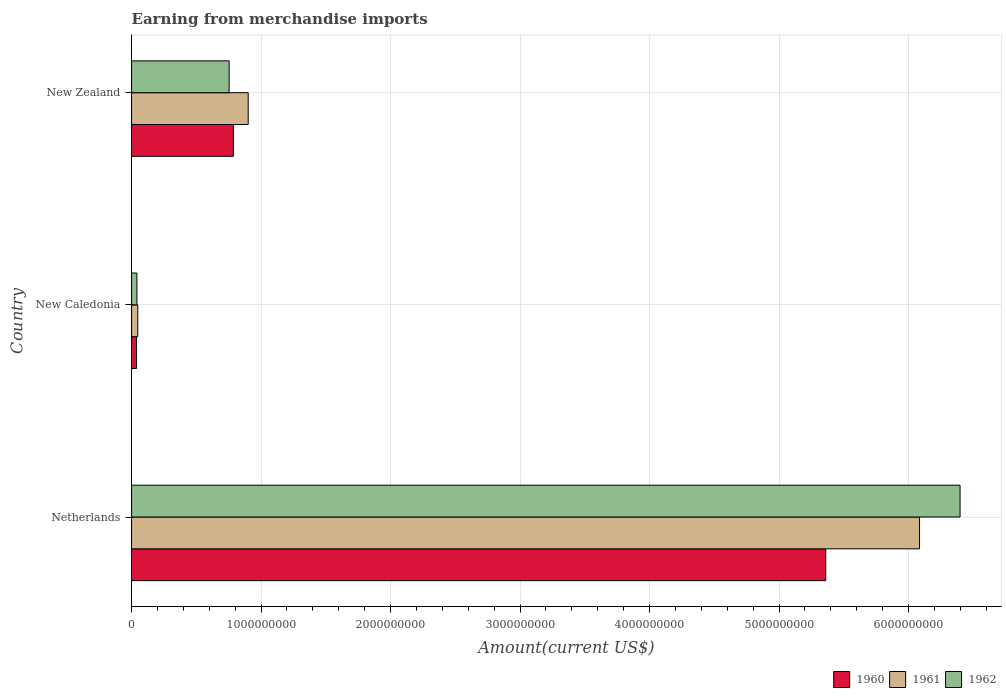How many different coloured bars are there?
Provide a short and direct response. 3. How many groups of bars are there?
Your answer should be compact. 3. Are the number of bars per tick equal to the number of legend labels?
Keep it short and to the point. Yes. Are the number of bars on each tick of the Y-axis equal?
Offer a terse response. Yes. How many bars are there on the 3rd tick from the bottom?
Make the answer very short. 3. What is the label of the 1st group of bars from the top?
Your response must be concise. New Zealand. What is the amount earned from merchandise imports in 1960 in Netherlands?
Make the answer very short. 5.36e+09. Across all countries, what is the maximum amount earned from merchandise imports in 1960?
Offer a very short reply. 5.36e+09. Across all countries, what is the minimum amount earned from merchandise imports in 1962?
Your response must be concise. 4.10e+07. In which country was the amount earned from merchandise imports in 1960 minimum?
Offer a very short reply. New Caledonia. What is the total amount earned from merchandise imports in 1961 in the graph?
Make the answer very short. 7.03e+09. What is the difference between the amount earned from merchandise imports in 1962 in New Caledonia and that in New Zealand?
Your answer should be very brief. -7.12e+08. What is the difference between the amount earned from merchandise imports in 1960 in New Zealand and the amount earned from merchandise imports in 1961 in Netherlands?
Keep it short and to the point. -5.30e+09. What is the average amount earned from merchandise imports in 1960 per country?
Provide a succinct answer. 2.06e+09. What is the difference between the amount earned from merchandise imports in 1960 and amount earned from merchandise imports in 1962 in New Zealand?
Keep it short and to the point. 3.28e+07. In how many countries, is the amount earned from merchandise imports in 1961 greater than 6000000000 US$?
Provide a short and direct response. 1. What is the ratio of the amount earned from merchandise imports in 1960 in Netherlands to that in New Caledonia?
Your answer should be compact. 141.08. What is the difference between the highest and the second highest amount earned from merchandise imports in 1960?
Provide a succinct answer. 4.57e+09. What is the difference between the highest and the lowest amount earned from merchandise imports in 1961?
Your answer should be compact. 6.04e+09. Is the sum of the amount earned from merchandise imports in 1961 in New Caledonia and New Zealand greater than the maximum amount earned from merchandise imports in 1962 across all countries?
Your answer should be compact. No. What does the 3rd bar from the top in Netherlands represents?
Your answer should be very brief. 1960. How many bars are there?
Provide a succinct answer. 9. What is the difference between two consecutive major ticks on the X-axis?
Give a very brief answer. 1.00e+09. Does the graph contain any zero values?
Offer a very short reply. No. Does the graph contain grids?
Your answer should be very brief. Yes. How are the legend labels stacked?
Give a very brief answer. Horizontal. What is the title of the graph?
Ensure brevity in your answer.  Earning from merchandise imports. Does "1963" appear as one of the legend labels in the graph?
Your answer should be compact. No. What is the label or title of the X-axis?
Offer a very short reply. Amount(current US$). What is the label or title of the Y-axis?
Keep it short and to the point. Country. What is the Amount(current US$) of 1960 in Netherlands?
Your answer should be very brief. 5.36e+09. What is the Amount(current US$) of 1961 in Netherlands?
Keep it short and to the point. 6.09e+09. What is the Amount(current US$) in 1962 in Netherlands?
Your response must be concise. 6.40e+09. What is the Amount(current US$) in 1960 in New Caledonia?
Give a very brief answer. 3.80e+07. What is the Amount(current US$) of 1961 in New Caledonia?
Offer a terse response. 4.80e+07. What is the Amount(current US$) of 1962 in New Caledonia?
Offer a very short reply. 4.10e+07. What is the Amount(current US$) of 1960 in New Zealand?
Give a very brief answer. 7.86e+08. What is the Amount(current US$) of 1961 in New Zealand?
Provide a succinct answer. 9.01e+08. What is the Amount(current US$) in 1962 in New Zealand?
Offer a terse response. 7.53e+08. Across all countries, what is the maximum Amount(current US$) in 1960?
Keep it short and to the point. 5.36e+09. Across all countries, what is the maximum Amount(current US$) of 1961?
Your response must be concise. 6.09e+09. Across all countries, what is the maximum Amount(current US$) of 1962?
Give a very brief answer. 6.40e+09. Across all countries, what is the minimum Amount(current US$) of 1960?
Provide a succinct answer. 3.80e+07. Across all countries, what is the minimum Amount(current US$) of 1961?
Offer a very short reply. 4.80e+07. Across all countries, what is the minimum Amount(current US$) in 1962?
Provide a short and direct response. 4.10e+07. What is the total Amount(current US$) of 1960 in the graph?
Your answer should be very brief. 6.19e+09. What is the total Amount(current US$) of 1961 in the graph?
Your answer should be compact. 7.03e+09. What is the total Amount(current US$) of 1962 in the graph?
Provide a succinct answer. 7.19e+09. What is the difference between the Amount(current US$) of 1960 in Netherlands and that in New Caledonia?
Provide a succinct answer. 5.32e+09. What is the difference between the Amount(current US$) in 1961 in Netherlands and that in New Caledonia?
Ensure brevity in your answer.  6.04e+09. What is the difference between the Amount(current US$) of 1962 in Netherlands and that in New Caledonia?
Your answer should be compact. 6.36e+09. What is the difference between the Amount(current US$) in 1960 in Netherlands and that in New Zealand?
Offer a very short reply. 4.57e+09. What is the difference between the Amount(current US$) of 1961 in Netherlands and that in New Zealand?
Ensure brevity in your answer.  5.18e+09. What is the difference between the Amount(current US$) of 1962 in Netherlands and that in New Zealand?
Make the answer very short. 5.64e+09. What is the difference between the Amount(current US$) in 1960 in New Caledonia and that in New Zealand?
Make the answer very short. -7.48e+08. What is the difference between the Amount(current US$) of 1961 in New Caledonia and that in New Zealand?
Provide a succinct answer. -8.53e+08. What is the difference between the Amount(current US$) of 1962 in New Caledonia and that in New Zealand?
Make the answer very short. -7.12e+08. What is the difference between the Amount(current US$) of 1960 in Netherlands and the Amount(current US$) of 1961 in New Caledonia?
Ensure brevity in your answer.  5.31e+09. What is the difference between the Amount(current US$) of 1960 in Netherlands and the Amount(current US$) of 1962 in New Caledonia?
Offer a terse response. 5.32e+09. What is the difference between the Amount(current US$) in 1961 in Netherlands and the Amount(current US$) in 1962 in New Caledonia?
Give a very brief answer. 6.04e+09. What is the difference between the Amount(current US$) in 1960 in Netherlands and the Amount(current US$) in 1961 in New Zealand?
Your answer should be compact. 4.46e+09. What is the difference between the Amount(current US$) in 1960 in Netherlands and the Amount(current US$) in 1962 in New Zealand?
Provide a short and direct response. 4.61e+09. What is the difference between the Amount(current US$) in 1961 in Netherlands and the Amount(current US$) in 1962 in New Zealand?
Provide a short and direct response. 5.33e+09. What is the difference between the Amount(current US$) of 1960 in New Caledonia and the Amount(current US$) of 1961 in New Zealand?
Offer a very short reply. -8.63e+08. What is the difference between the Amount(current US$) of 1960 in New Caledonia and the Amount(current US$) of 1962 in New Zealand?
Make the answer very short. -7.15e+08. What is the difference between the Amount(current US$) of 1961 in New Caledonia and the Amount(current US$) of 1962 in New Zealand?
Offer a very short reply. -7.05e+08. What is the average Amount(current US$) of 1960 per country?
Your answer should be compact. 2.06e+09. What is the average Amount(current US$) of 1961 per country?
Your answer should be compact. 2.34e+09. What is the average Amount(current US$) in 1962 per country?
Your answer should be very brief. 2.40e+09. What is the difference between the Amount(current US$) of 1960 and Amount(current US$) of 1961 in Netherlands?
Provide a succinct answer. -7.24e+08. What is the difference between the Amount(current US$) in 1960 and Amount(current US$) in 1962 in Netherlands?
Make the answer very short. -1.04e+09. What is the difference between the Amount(current US$) of 1961 and Amount(current US$) of 1962 in Netherlands?
Offer a very short reply. -3.13e+08. What is the difference between the Amount(current US$) of 1960 and Amount(current US$) of 1961 in New Caledonia?
Provide a succinct answer. -1.00e+07. What is the difference between the Amount(current US$) in 1960 and Amount(current US$) in 1962 in New Caledonia?
Keep it short and to the point. -3.00e+06. What is the difference between the Amount(current US$) of 1960 and Amount(current US$) of 1961 in New Zealand?
Provide a succinct answer. -1.14e+08. What is the difference between the Amount(current US$) in 1960 and Amount(current US$) in 1962 in New Zealand?
Make the answer very short. 3.28e+07. What is the difference between the Amount(current US$) in 1961 and Amount(current US$) in 1962 in New Zealand?
Your answer should be compact. 1.47e+08. What is the ratio of the Amount(current US$) of 1960 in Netherlands to that in New Caledonia?
Your answer should be very brief. 141.08. What is the ratio of the Amount(current US$) in 1961 in Netherlands to that in New Caledonia?
Make the answer very short. 126.78. What is the ratio of the Amount(current US$) in 1962 in Netherlands to that in New Caledonia?
Your response must be concise. 156.06. What is the ratio of the Amount(current US$) in 1960 in Netherlands to that in New Zealand?
Provide a succinct answer. 6.82. What is the ratio of the Amount(current US$) of 1961 in Netherlands to that in New Zealand?
Make the answer very short. 6.76. What is the ratio of the Amount(current US$) in 1962 in Netherlands to that in New Zealand?
Offer a terse response. 8.49. What is the ratio of the Amount(current US$) of 1960 in New Caledonia to that in New Zealand?
Provide a succinct answer. 0.05. What is the ratio of the Amount(current US$) in 1961 in New Caledonia to that in New Zealand?
Keep it short and to the point. 0.05. What is the ratio of the Amount(current US$) of 1962 in New Caledonia to that in New Zealand?
Provide a succinct answer. 0.05. What is the difference between the highest and the second highest Amount(current US$) of 1960?
Provide a succinct answer. 4.57e+09. What is the difference between the highest and the second highest Amount(current US$) in 1961?
Your response must be concise. 5.18e+09. What is the difference between the highest and the second highest Amount(current US$) of 1962?
Your response must be concise. 5.64e+09. What is the difference between the highest and the lowest Amount(current US$) of 1960?
Offer a very short reply. 5.32e+09. What is the difference between the highest and the lowest Amount(current US$) of 1961?
Ensure brevity in your answer.  6.04e+09. What is the difference between the highest and the lowest Amount(current US$) of 1962?
Your answer should be compact. 6.36e+09. 